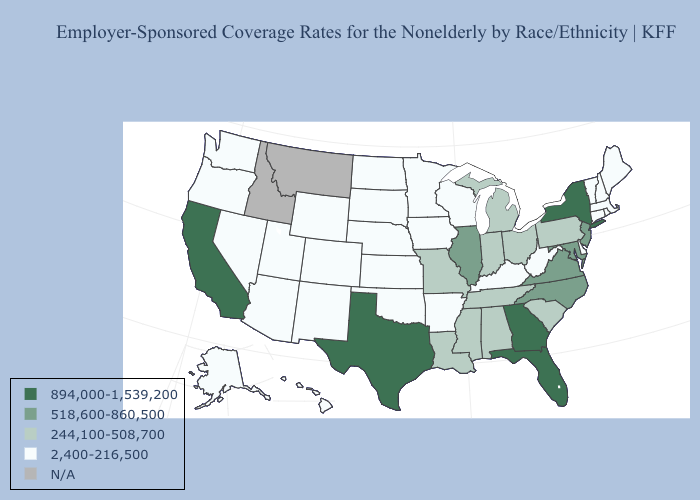Does the map have missing data?
Answer briefly. Yes. Does the first symbol in the legend represent the smallest category?
Concise answer only. No. What is the lowest value in the Northeast?
Keep it brief. 2,400-216,500. Does the first symbol in the legend represent the smallest category?
Quick response, please. No. What is the value of North Dakota?
Concise answer only. 2,400-216,500. Is the legend a continuous bar?
Short answer required. No. What is the value of New York?
Give a very brief answer. 894,000-1,539,200. Name the states that have a value in the range N/A?
Concise answer only. Idaho, Montana. What is the lowest value in the MidWest?
Write a very short answer. 2,400-216,500. Name the states that have a value in the range 244,100-508,700?
Write a very short answer. Alabama, Indiana, Louisiana, Michigan, Mississippi, Missouri, Ohio, Pennsylvania, South Carolina, Tennessee. What is the lowest value in the South?
Write a very short answer. 2,400-216,500. What is the value of Nebraska?
Write a very short answer. 2,400-216,500. Name the states that have a value in the range 2,400-216,500?
Give a very brief answer. Alaska, Arizona, Arkansas, Colorado, Connecticut, Delaware, Hawaii, Iowa, Kansas, Kentucky, Maine, Massachusetts, Minnesota, Nebraska, Nevada, New Hampshire, New Mexico, North Dakota, Oklahoma, Oregon, Rhode Island, South Dakota, Utah, Vermont, Washington, West Virginia, Wisconsin, Wyoming. 